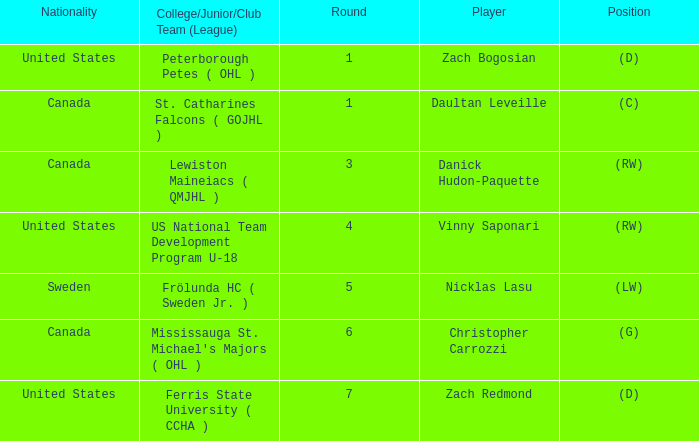What is the Player in Round 5? Nicklas Lasu. Would you mind parsing the complete table? {'header': ['Nationality', 'College/Junior/Club Team (League)', 'Round', 'Player', 'Position'], 'rows': [['United States', 'Peterborough Petes ( OHL )', '1', 'Zach Bogosian', '(D)'], ['Canada', 'St. Catharines Falcons ( GOJHL )', '1', 'Daultan Leveille', '(C)'], ['Canada', 'Lewiston Maineiacs ( QMJHL )', '3', 'Danick Hudon-Paquette', '(RW)'], ['United States', 'US National Team Development Program U-18', '4', 'Vinny Saponari', '(RW)'], ['Sweden', 'Frölunda HC ( Sweden Jr. )', '5', 'Nicklas Lasu', '(LW)'], ['Canada', "Mississauga St. Michael's Majors ( OHL )", '6', 'Christopher Carrozzi', '(G)'], ['United States', 'Ferris State University ( CCHA )', '7', 'Zach Redmond', '(D)']]} 